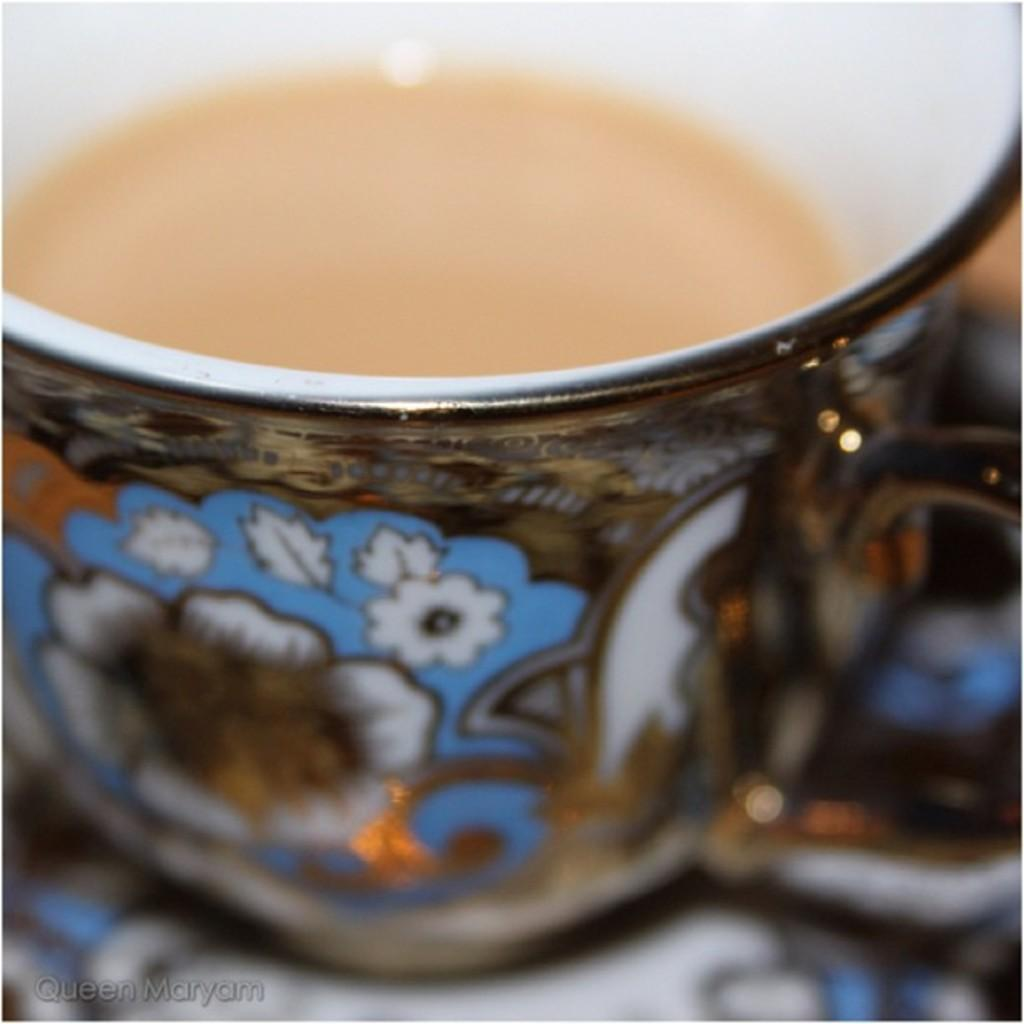What is the main object in the image? There is a teacup in the image. Is the teacup placed on any surface? Yes, the teacup is on a saucer. What else can be seen in the image? There is edited text in the bottom left of the image. Where is the library located in the image? There is no library present in the image. What type of form is being filled out in the image? There is no form visible in the image. 